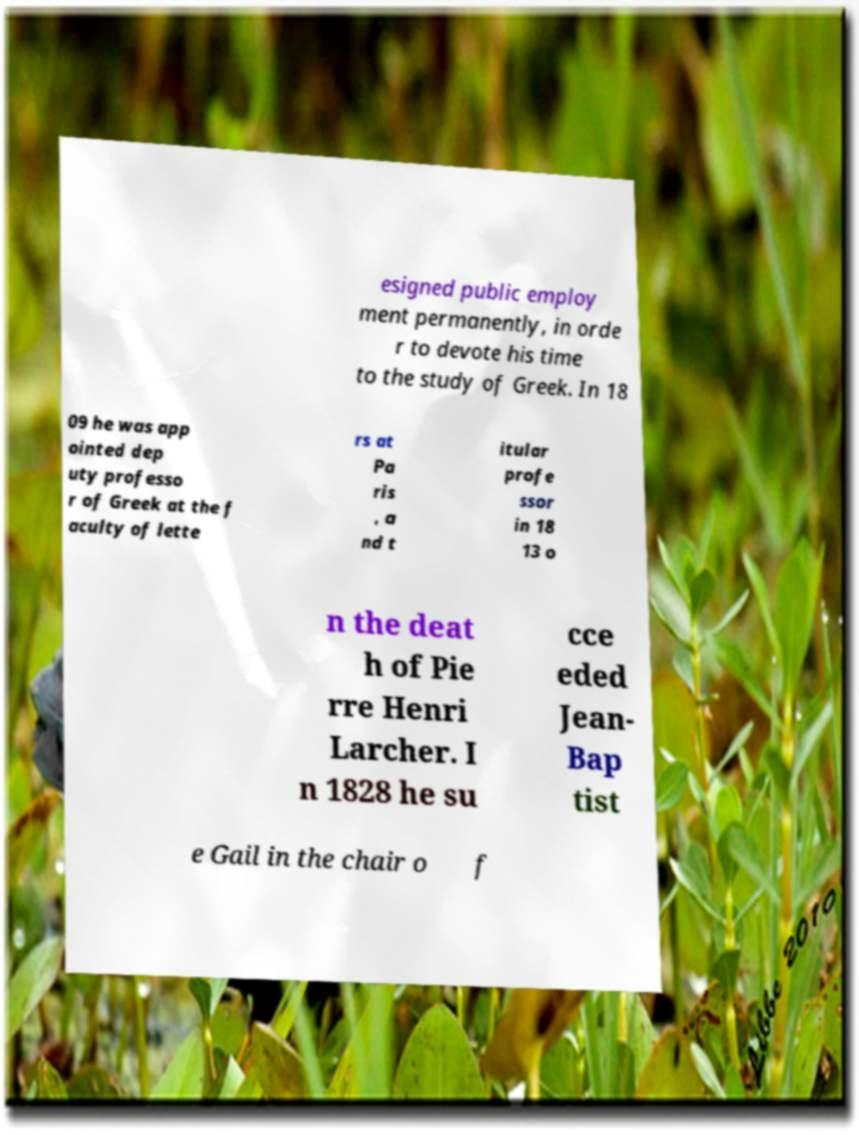Could you extract and type out the text from this image? esigned public employ ment permanently, in orde r to devote his time to the study of Greek. In 18 09 he was app ointed dep uty professo r of Greek at the f aculty of lette rs at Pa ris , a nd t itular profe ssor in 18 13 o n the deat h of Pie rre Henri Larcher. I n 1828 he su cce eded Jean- Bap tist e Gail in the chair o f 